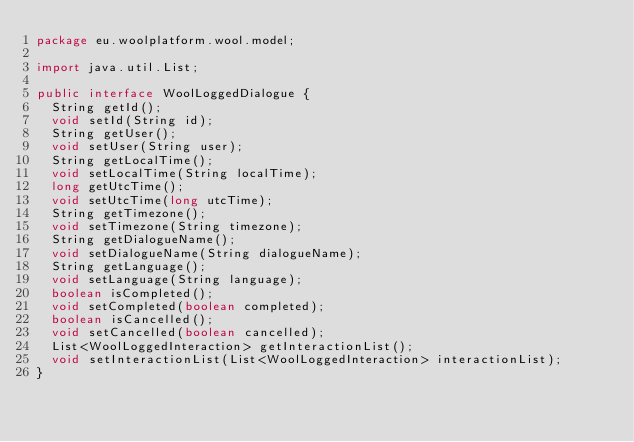Convert code to text. <code><loc_0><loc_0><loc_500><loc_500><_Java_>package eu.woolplatform.wool.model;

import java.util.List;

public interface WoolLoggedDialogue {
	String getId();
	void setId(String id);
	String getUser();
	void setUser(String user);
	String getLocalTime();
	void setLocalTime(String localTime);
	long getUtcTime();
	void setUtcTime(long utcTime);
	String getTimezone();
	void setTimezone(String timezone);
	String getDialogueName();
	void setDialogueName(String dialogueName);
	String getLanguage();
	void setLanguage(String language);
	boolean isCompleted();
	void setCompleted(boolean completed);
	boolean isCancelled();
	void setCancelled(boolean cancelled);
	List<WoolLoggedInteraction> getInteractionList();
	void setInteractionList(List<WoolLoggedInteraction> interactionList);
}
</code> 